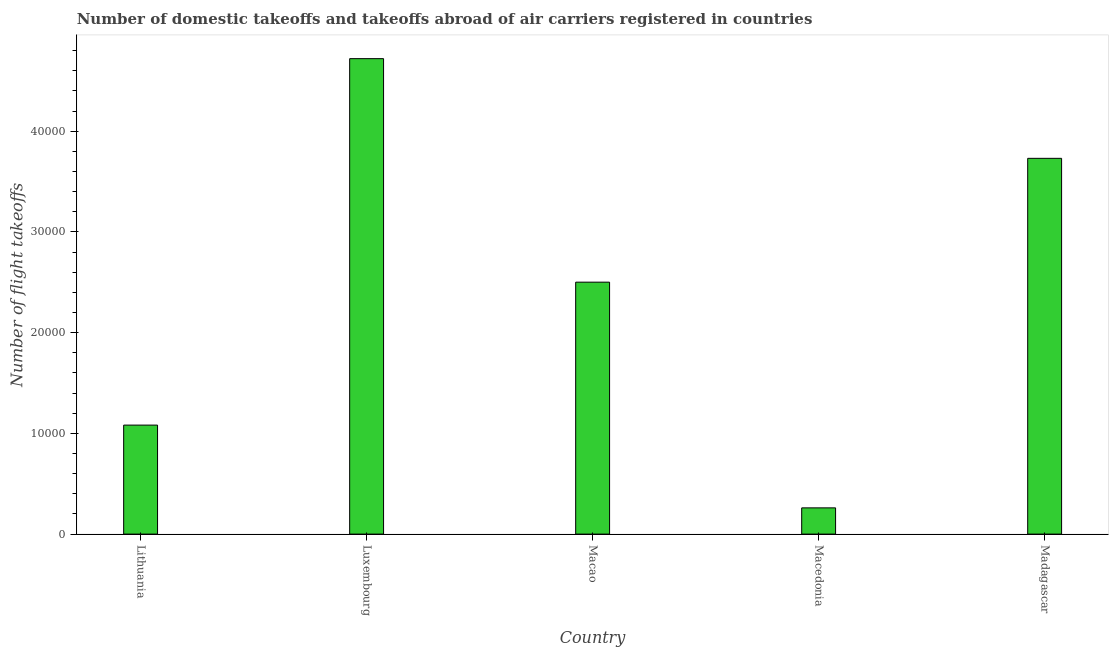Does the graph contain grids?
Your answer should be compact. No. What is the title of the graph?
Provide a short and direct response. Number of domestic takeoffs and takeoffs abroad of air carriers registered in countries. What is the label or title of the Y-axis?
Offer a terse response. Number of flight takeoffs. What is the number of flight takeoffs in Macao?
Provide a short and direct response. 2.50e+04. Across all countries, what is the maximum number of flight takeoffs?
Ensure brevity in your answer.  4.72e+04. Across all countries, what is the minimum number of flight takeoffs?
Provide a succinct answer. 2605. In which country was the number of flight takeoffs maximum?
Provide a succinct answer. Luxembourg. In which country was the number of flight takeoffs minimum?
Provide a succinct answer. Macedonia. What is the sum of the number of flight takeoffs?
Offer a terse response. 1.23e+05. What is the difference between the number of flight takeoffs in Lithuania and Luxembourg?
Offer a terse response. -3.64e+04. What is the average number of flight takeoffs per country?
Keep it short and to the point. 2.46e+04. What is the median number of flight takeoffs?
Your answer should be very brief. 2.50e+04. In how many countries, is the number of flight takeoffs greater than 16000 ?
Your response must be concise. 3. What is the ratio of the number of flight takeoffs in Luxembourg to that in Macao?
Your answer should be very brief. 1.89. Is the number of flight takeoffs in Luxembourg less than that in Macedonia?
Keep it short and to the point. No. What is the difference between the highest and the second highest number of flight takeoffs?
Make the answer very short. 9899. What is the difference between the highest and the lowest number of flight takeoffs?
Ensure brevity in your answer.  4.46e+04. How many bars are there?
Your answer should be very brief. 5. How many countries are there in the graph?
Ensure brevity in your answer.  5. What is the difference between two consecutive major ticks on the Y-axis?
Your answer should be compact. 10000. Are the values on the major ticks of Y-axis written in scientific E-notation?
Your answer should be very brief. No. What is the Number of flight takeoffs of Lithuania?
Provide a succinct answer. 1.08e+04. What is the Number of flight takeoffs of Luxembourg?
Make the answer very short. 4.72e+04. What is the Number of flight takeoffs in Macao?
Give a very brief answer. 2.50e+04. What is the Number of flight takeoffs in Macedonia?
Ensure brevity in your answer.  2605. What is the Number of flight takeoffs of Madagascar?
Ensure brevity in your answer.  3.73e+04. What is the difference between the Number of flight takeoffs in Lithuania and Luxembourg?
Offer a terse response. -3.64e+04. What is the difference between the Number of flight takeoffs in Lithuania and Macao?
Give a very brief answer. -1.42e+04. What is the difference between the Number of flight takeoffs in Lithuania and Macedonia?
Offer a very short reply. 8218. What is the difference between the Number of flight takeoffs in Lithuania and Madagascar?
Your answer should be compact. -2.65e+04. What is the difference between the Number of flight takeoffs in Luxembourg and Macao?
Make the answer very short. 2.22e+04. What is the difference between the Number of flight takeoffs in Luxembourg and Macedonia?
Offer a very short reply. 4.46e+04. What is the difference between the Number of flight takeoffs in Luxembourg and Madagascar?
Give a very brief answer. 9899. What is the difference between the Number of flight takeoffs in Macao and Macedonia?
Ensure brevity in your answer.  2.24e+04. What is the difference between the Number of flight takeoffs in Macao and Madagascar?
Keep it short and to the point. -1.23e+04. What is the difference between the Number of flight takeoffs in Macedonia and Madagascar?
Offer a terse response. -3.47e+04. What is the ratio of the Number of flight takeoffs in Lithuania to that in Luxembourg?
Your answer should be compact. 0.23. What is the ratio of the Number of flight takeoffs in Lithuania to that in Macao?
Your response must be concise. 0.43. What is the ratio of the Number of flight takeoffs in Lithuania to that in Macedonia?
Make the answer very short. 4.16. What is the ratio of the Number of flight takeoffs in Lithuania to that in Madagascar?
Make the answer very short. 0.29. What is the ratio of the Number of flight takeoffs in Luxembourg to that in Macao?
Ensure brevity in your answer.  1.89. What is the ratio of the Number of flight takeoffs in Luxembourg to that in Macedonia?
Make the answer very short. 18.12. What is the ratio of the Number of flight takeoffs in Luxembourg to that in Madagascar?
Provide a short and direct response. 1.26. What is the ratio of the Number of flight takeoffs in Macao to that in Macedonia?
Provide a succinct answer. 9.6. What is the ratio of the Number of flight takeoffs in Macao to that in Madagascar?
Offer a terse response. 0.67. What is the ratio of the Number of flight takeoffs in Macedonia to that in Madagascar?
Provide a succinct answer. 0.07. 